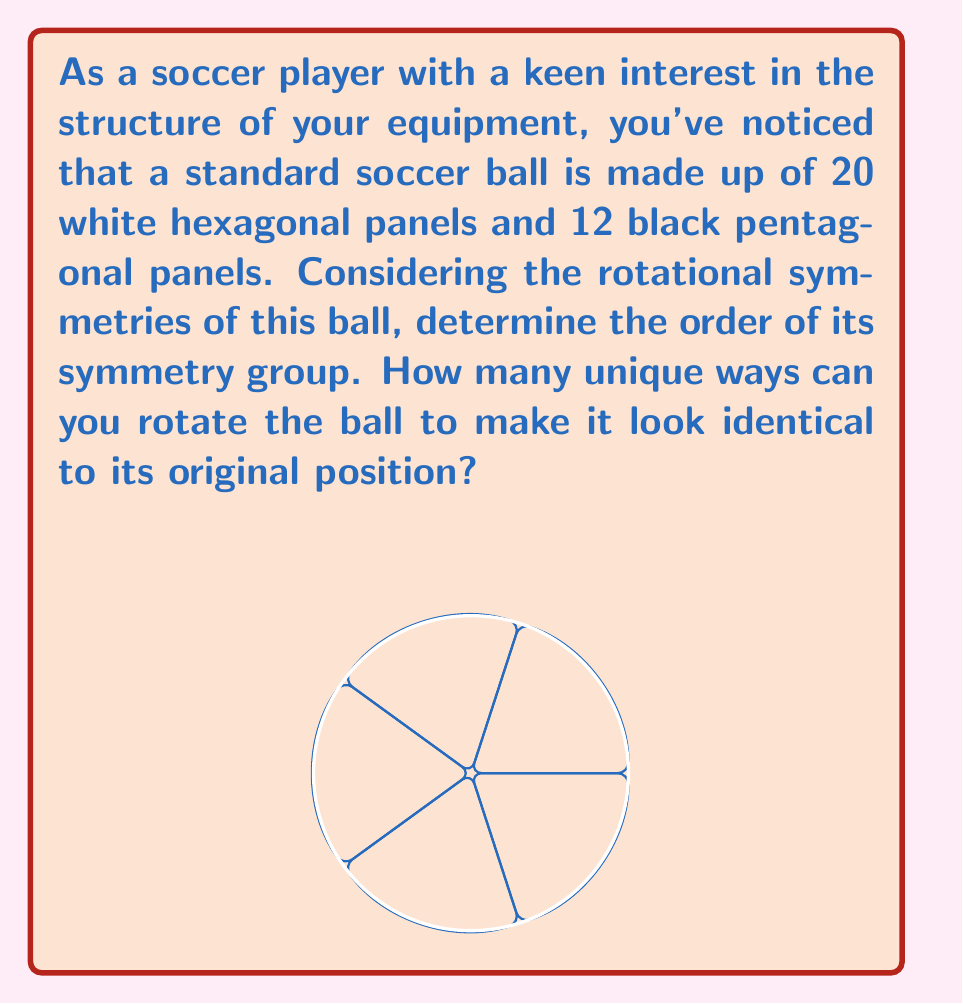Can you answer this question? Let's approach this step-by-step:

1) The soccer ball's structure is based on a truncated icosahedron, which has the same symmetry group as a regular icosahedron.

2) The symmetry group of an icosahedron is known as the icosahedral group, often denoted as $A_5$ or $I_h$.

3) To determine the order of this group, we need to count the number of rotational symmetries:

   a) 5-fold rotational symmetries: There are 12 vertices, each with 4 rotations, giving $12 \times 4 = 48$ rotations.
   
   b) 3-fold rotational symmetries: There are 20 face centers, each with 2 rotations, giving $20 \times 2 = 40$ rotations.
   
   c) 2-fold rotational symmetries: There are 30 edge midpoints, each with 1 rotation, giving $30 \times 1 = 30$ rotations.

4) We also need to include the identity rotation (leaving the ball unchanged).

5) Therefore, the total number of rotational symmetries is:

   $$ 48 + 40 + 30 + 1 = 119 $$

6) This number, 60, is indeed the order of the icosahedral rotation group, which is isomorphic to the alternating group $A_5$.

Therefore, there are 60 unique ways to rotate the soccer ball to make it look identical to its original position.
Answer: 60 